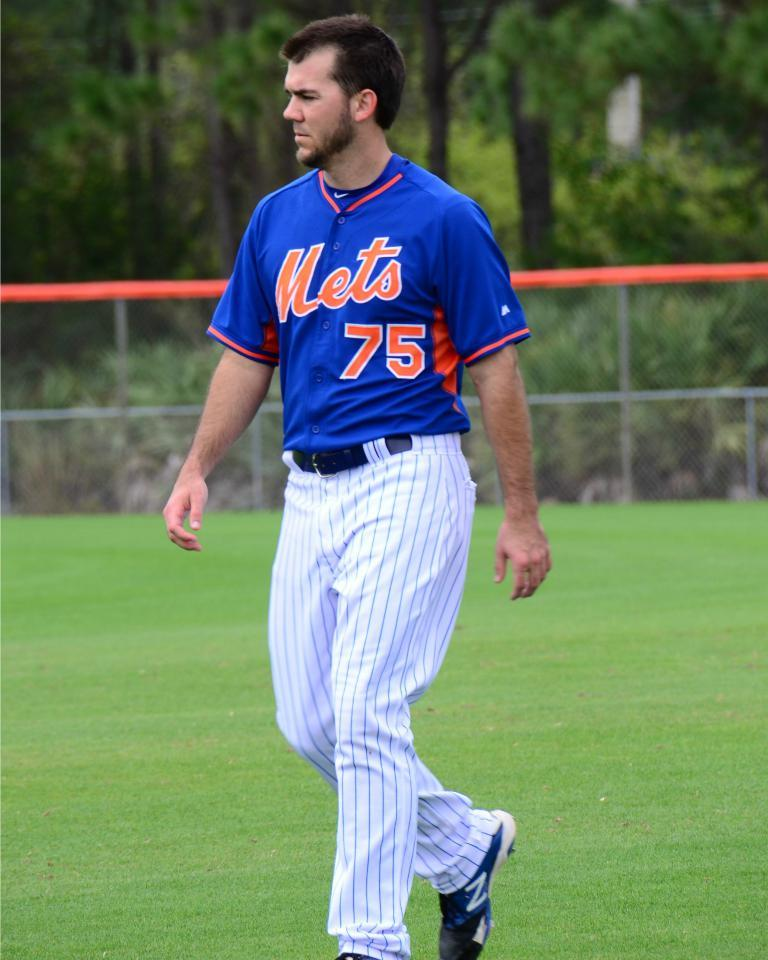Provide a one-sentence caption for the provided image. A Mets player walks across the field without a glove on. 